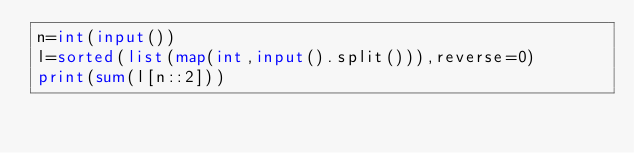Convert code to text. <code><loc_0><loc_0><loc_500><loc_500><_Python_>n=int(input())
l=sorted(list(map(int,input().split())),reverse=0)
print(sum(l[n::2]))</code> 